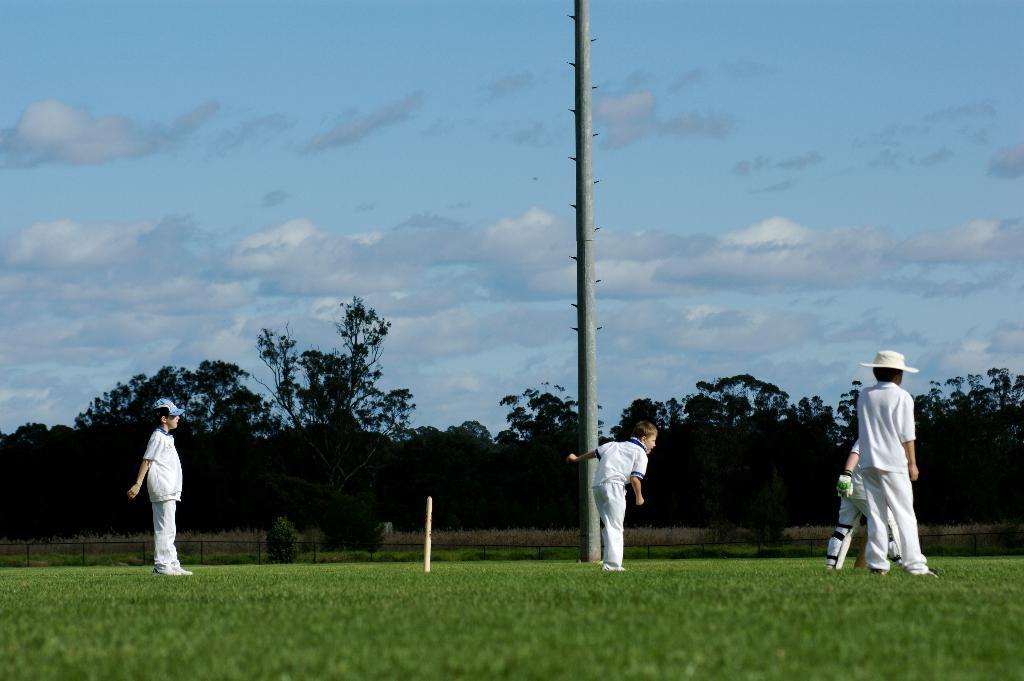Could you give a brief overview of what you see in this image? In this image I can see few people are standing and wearing white color dresses. I can see few trees, fencing, pole and a wicket. The sky is in blue and white color. 